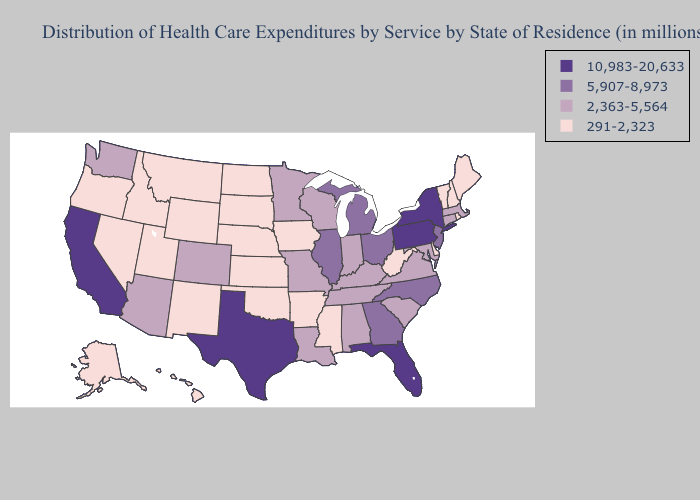Among the states that border Wisconsin , does Iowa have the highest value?
Quick response, please. No. Does Pennsylvania have the lowest value in the Northeast?
Short answer required. No. Name the states that have a value in the range 5,907-8,973?
Short answer required. Georgia, Illinois, Michigan, New Jersey, North Carolina, Ohio. What is the value of Florida?
Write a very short answer. 10,983-20,633. What is the lowest value in the South?
Write a very short answer. 291-2,323. Name the states that have a value in the range 291-2,323?
Answer briefly. Alaska, Arkansas, Delaware, Hawaii, Idaho, Iowa, Kansas, Maine, Mississippi, Montana, Nebraska, Nevada, New Hampshire, New Mexico, North Dakota, Oklahoma, Oregon, Rhode Island, South Dakota, Utah, Vermont, West Virginia, Wyoming. What is the value of Kansas?
Quick response, please. 291-2,323. Does Alabama have the highest value in the South?
Give a very brief answer. No. Among the states that border Oklahoma , which have the highest value?
Write a very short answer. Texas. Which states have the lowest value in the USA?
Give a very brief answer. Alaska, Arkansas, Delaware, Hawaii, Idaho, Iowa, Kansas, Maine, Mississippi, Montana, Nebraska, Nevada, New Hampshire, New Mexico, North Dakota, Oklahoma, Oregon, Rhode Island, South Dakota, Utah, Vermont, West Virginia, Wyoming. Among the states that border Massachusetts , does New York have the highest value?
Write a very short answer. Yes. What is the value of Alaska?
Quick response, please. 291-2,323. What is the highest value in the Northeast ?
Give a very brief answer. 10,983-20,633. Name the states that have a value in the range 2,363-5,564?
Keep it brief. Alabama, Arizona, Colorado, Connecticut, Indiana, Kentucky, Louisiana, Maryland, Massachusetts, Minnesota, Missouri, South Carolina, Tennessee, Virginia, Washington, Wisconsin. What is the value of Nevada?
Write a very short answer. 291-2,323. 